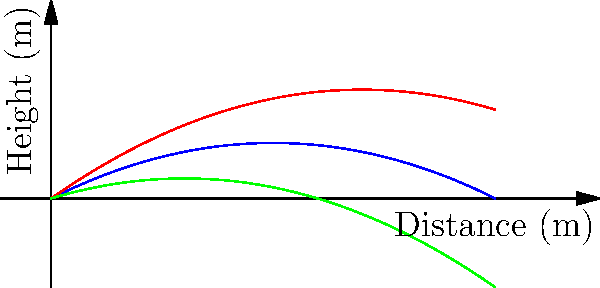Based on the graph showing the trajectories of tennis serves with different spin types, which spin type would be most effective for serving an ace (unreturnable serve) on a fast court surface? To answer this question, let's analyze the trajectories of each spin type:

1. Flat serve (blue line):
   - Follows a moderate arc
   - Reaches a medium height
   - Has a consistent, predictable bounce

2. Topspin serve (red line):
   - Has the highest arc
   - Reaches the greatest height
   - Bounces higher after impact

3. Slice serve (green line):
   - Has the lowest arc
   - Stays closest to the ground
   - Tends to skid and stay low after bouncing

On a fast court surface (e.g., grass or hard court), the ball travels quickly and doesn't bounce as high. The ideal serve would be one that:
   a) Reaches the opponent quickly
   b) Stays low after bouncing
   c) Is difficult to return due to its speed and low bounce

Given these factors, the slice serve (green line) would be most effective for serving an ace on a fast court surface because:
   - It has the lowest trajectory, making it harder for the opponent to reach
   - It will likely skid and stay low after bouncing, giving the opponent less time to react
   - The low bounce is particularly challenging on fast surfaces where the ball already doesn't bounce high

The flat serve could also be effective, but the slice serve's lower trajectory gives it a slight advantage for aces on fast courts.
Answer: Slice serve 